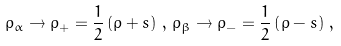<formula> <loc_0><loc_0><loc_500><loc_500>\rho _ { \alpha } \rightarrow \rho _ { + } = \frac { 1 } { 2 } \left ( \rho + s \right ) \, , \, \rho _ { \beta } \rightarrow \rho _ { - } = \frac { 1 } { 2 } \left ( \rho - s \right ) \, ,</formula> 